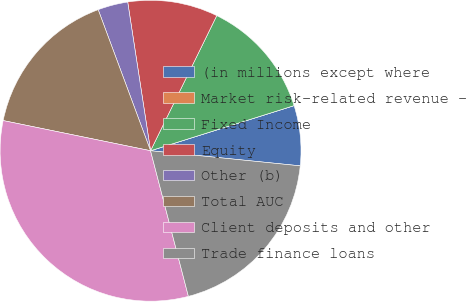Convert chart. <chart><loc_0><loc_0><loc_500><loc_500><pie_chart><fcel>(in millions except where<fcel>Market risk-related revenue -<fcel>Fixed Income<fcel>Equity<fcel>Other (b)<fcel>Total AUC<fcel>Client deposits and other<fcel>Trade finance loans<nl><fcel>6.45%<fcel>0.0%<fcel>12.9%<fcel>9.68%<fcel>3.23%<fcel>16.13%<fcel>32.26%<fcel>19.35%<nl></chart> 